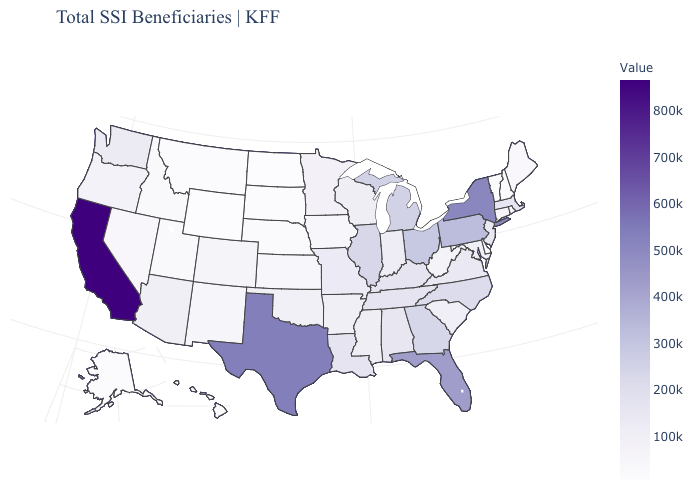Which states hav the highest value in the Northeast?
Short answer required. New York. Which states hav the highest value in the Northeast?
Concise answer only. New York. Does the map have missing data?
Quick response, please. No. Is the legend a continuous bar?
Give a very brief answer. Yes. 